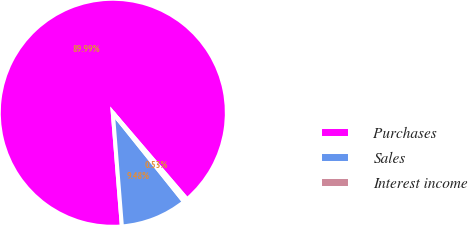<chart> <loc_0><loc_0><loc_500><loc_500><pie_chart><fcel>Purchases<fcel>Sales<fcel>Interest income<nl><fcel>89.99%<fcel>9.48%<fcel>0.53%<nl></chart> 